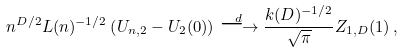Convert formula to latex. <formula><loc_0><loc_0><loc_500><loc_500>n ^ { D / 2 } L ( n ) ^ { - 1 / 2 } \left ( U _ { n , 2 } - U _ { 2 } ( 0 ) \right ) \stackrel { d } { \longrightarrow } \frac { k ( D ) ^ { - 1 / 2 } } { \sqrt { \pi } } Z _ { 1 , D } ( 1 ) \, ,</formula> 